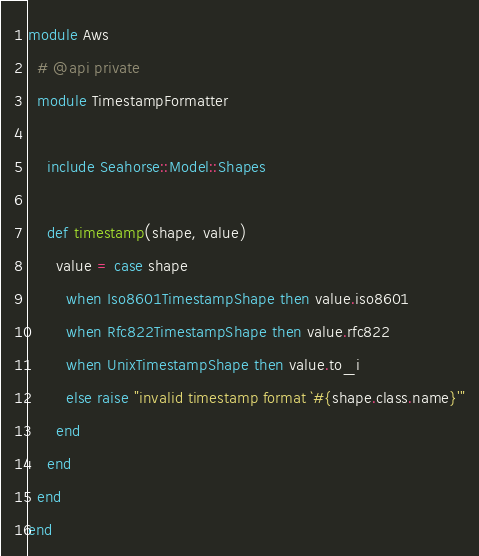Convert code to text. <code><loc_0><loc_0><loc_500><loc_500><_Ruby_>module Aws
  # @api private
  module TimestampFormatter

    include Seahorse::Model::Shapes

    def timestamp(shape, value)
      value = case shape
        when Iso8601TimestampShape then value.iso8601
        when Rfc822TimestampShape then value.rfc822
        when UnixTimestampShape then value.to_i
        else raise "invalid timestamp format `#{shape.class.name}'"
      end
    end
  end
end
</code> 